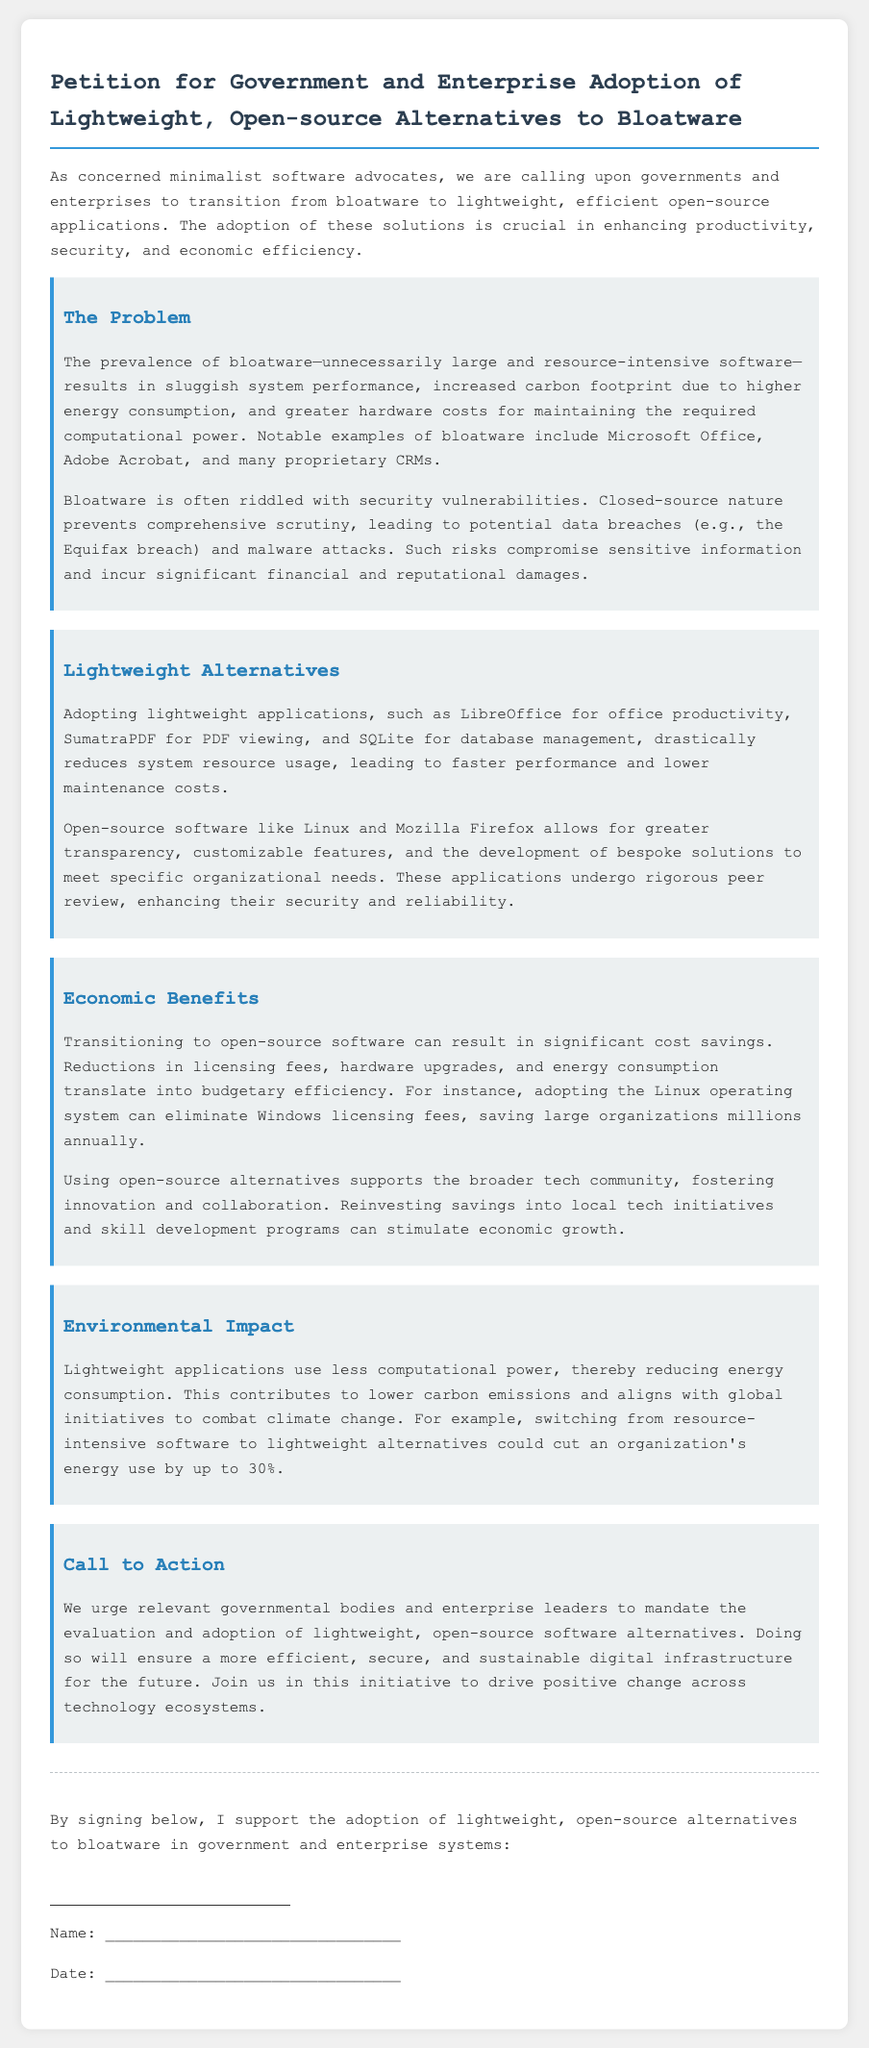What is the title of the petition? The title of the petition is stated clearly at the top of the document.
Answer: Petition for Government and Enterprise Adoption of Lightweight, Open-source Alternatives to Bloatware What are examples of bloatware mentioned? The document lists specific software as examples of bloatware.
Answer: Microsoft Office, Adobe Acrobat What are lightweight alternatives to office productivity software? The document provides a specific example of a lightweight alternative for office productivity.
Answer: LibreOffice What is the potential reduction in energy use by switching to lightweight software? The document mentions the percentage decrease in energy use associated with switching.
Answer: up to 30% What type of software does the petition advocate for? The petition advocates for a specific category of software solutions.
Answer: Lightweight, open-source What is one economic benefit of transitioning to open-source software? The document outlines financial advantages of adopting open-source software.
Answer: Cost savings What security issue is associated with bloatware? The document mentions a specific concern related to the security of bloatware.
Answer: Security vulnerabilities Which organization's breach is referenced as an example? The document refers to a specific incident regarding data breach concerns.
Answer: Equifax What is the call to action stated in the petition? The document concludes with a specific appeal for action from governmental bodies and enterprise leaders.
Answer: Evaluate and adopt lightweight, open-source software alternatives 